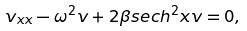Convert formula to latex. <formula><loc_0><loc_0><loc_500><loc_500>v _ { x x } - \omega ^ { 2 } v + 2 \beta s e c h ^ { 2 } x v = 0 ,</formula> 